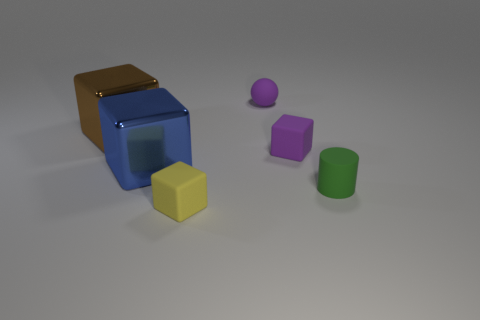Are there any rubber objects that have the same color as the ball?
Offer a terse response. Yes. There is a rubber thing that is the same color as the tiny ball; what is its size?
Provide a succinct answer. Small. The green matte thing has what shape?
Your response must be concise. Cylinder. What is the shape of the purple matte thing that is in front of the purple sphere that is on the right side of the big metallic object in front of the big brown metallic block?
Keep it short and to the point. Cube. What number of other objects are the same shape as the large blue metal object?
Offer a very short reply. 3. There is a tiny thing that is behind the rubber block behind the blue shiny object; what is its material?
Your answer should be very brief. Rubber. Are the tiny green object and the large blue object that is left of the small ball made of the same material?
Make the answer very short. No. What material is the small thing that is in front of the big brown shiny thing and behind the small cylinder?
Your response must be concise. Rubber. What color is the tiny rubber object that is behind the cube that is right of the tiny purple ball?
Provide a succinct answer. Purple. There is a block that is to the left of the blue metal cube; what material is it?
Ensure brevity in your answer.  Metal. 